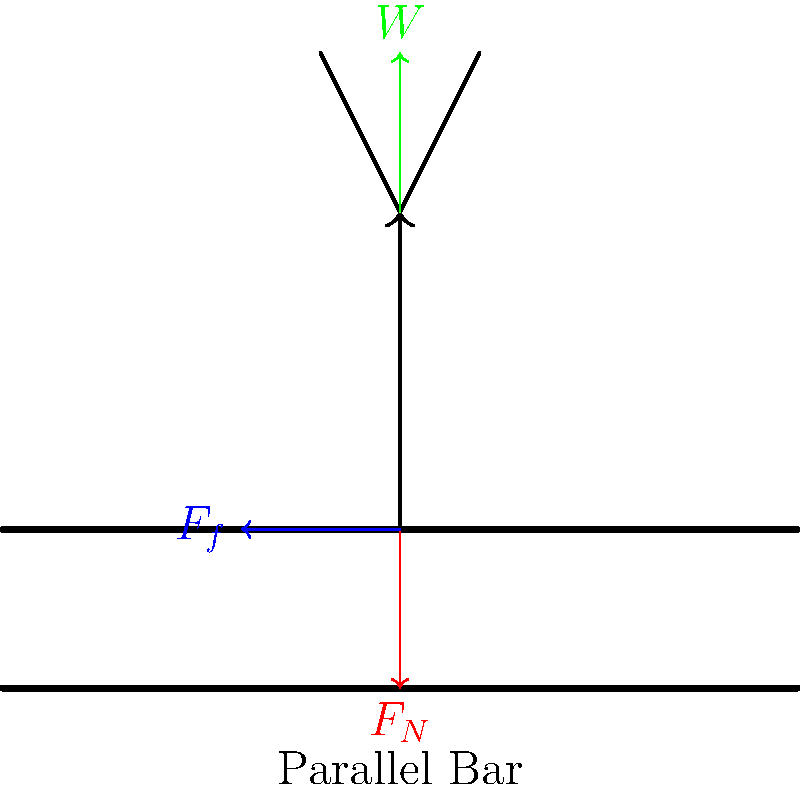A gymnast performing on parallel bars experiences three main forces: their weight (W), the normal force (F_N) from the bar, and friction (F_f) between their hands and the bar. If the gymnast's mass is 65 kg and they are momentarily stationary in a handstand position, calculate the magnitude of the friction force required to maintain equilibrium. Assume g = 9.8 m/s^2 and the coefficient of static friction between the gymnast's hands and the bar is 0.75. To solve this problem, we'll follow these steps:

1) First, let's identify the forces acting on the gymnast:
   - Weight (W): Acts downward
   - Normal force (F_N): Acts upward
   - Friction force (F_f): Acts horizontally

2) In equilibrium, the sum of forces in both vertical and horizontal directions must be zero.

3) Vertical forces:
   $$F_N - W = 0$$
   $$F_N = W = mg = 65 \times 9.8 = 637 \text{ N}$$

4) The friction force prevents the gymnast from sliding off the bar. It must be equal and opposite to the horizontal component of the normal force.

5) The angle between the vertical and the gymnast's arms isn't given, so we need to use the coefficient of static friction (μ):
   $$F_f = \mu F_N$$

6) Substitute the values:
   $$F_f = 0.75 \times 637 = 477.75 \text{ N}$$

Therefore, the friction force required to maintain equilibrium is 477.75 N.
Answer: 477.75 N 